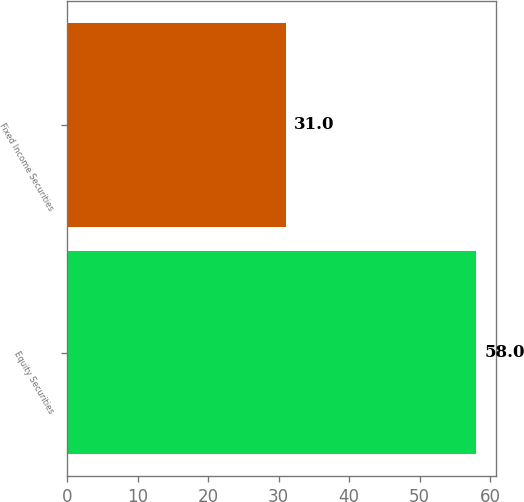Convert chart to OTSL. <chart><loc_0><loc_0><loc_500><loc_500><bar_chart><fcel>Equity Securities<fcel>Fixed Income Securities<nl><fcel>58<fcel>31<nl></chart> 